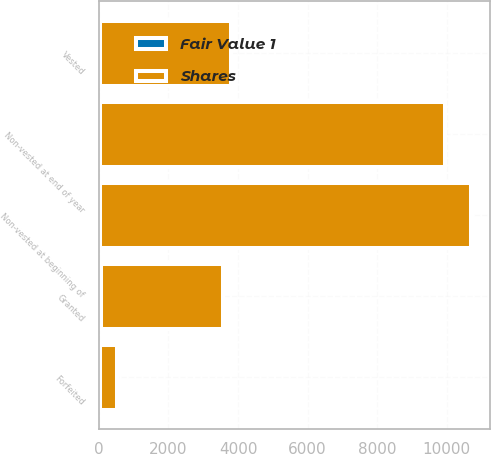Convert chart. <chart><loc_0><loc_0><loc_500><loc_500><stacked_bar_chart><ecel><fcel>Non-vested at beginning of<fcel>Granted<fcel>Vested<fcel>Forfeited<fcel>Non-vested at end of year<nl><fcel>Shares<fcel>10674<fcel>3506<fcel>3773<fcel>491<fcel>9916<nl><fcel>Fair Value 1<fcel>38<fcel>51<fcel>39<fcel>39<fcel>42<nl></chart> 